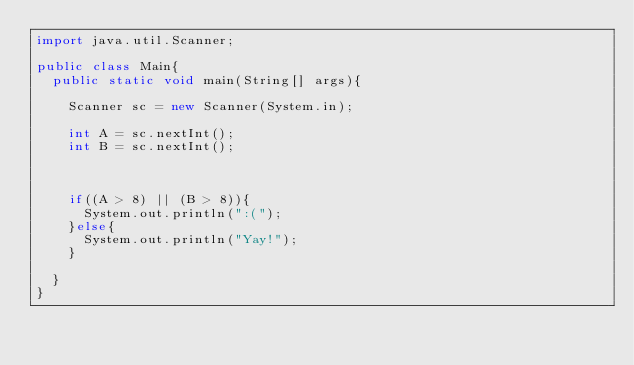<code> <loc_0><loc_0><loc_500><loc_500><_Java_>import java.util.Scanner;

public class Main{
  public static void main(String[] args){

    Scanner sc = new Scanner(System.in);

    int A = sc.nextInt();
    int B = sc.nextInt();

    

    if((A > 8) || (B > 8)){
      System.out.println(":(");
    }else{
      System.out.println("Yay!");
    }

  }
}</code> 